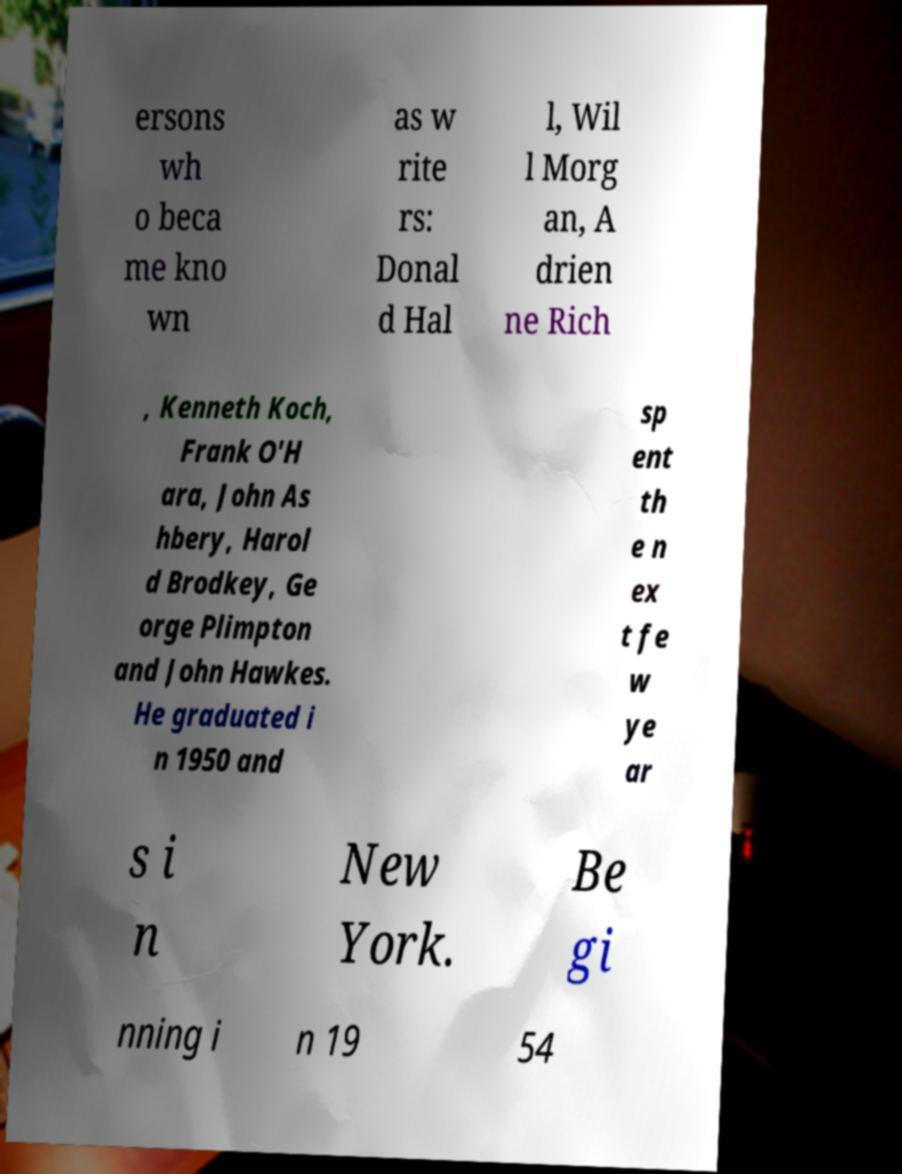Could you assist in decoding the text presented in this image and type it out clearly? ersons wh o beca me kno wn as w rite rs: Donal d Hal l, Wil l Morg an, A drien ne Rich , Kenneth Koch, Frank O'H ara, John As hbery, Harol d Brodkey, Ge orge Plimpton and John Hawkes. He graduated i n 1950 and sp ent th e n ex t fe w ye ar s i n New York. Be gi nning i n 19 54 